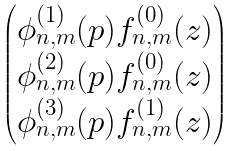Convert formula to latex. <formula><loc_0><loc_0><loc_500><loc_500>\begin{pmatrix} \phi _ { n , m } ^ { ( 1 ) } ( p ) f _ { n , m } ^ { ( 0 ) } ( z ) \\ \phi _ { n , m } ^ { ( 2 ) } ( p ) f _ { n , m } ^ { ( 0 ) } ( z ) \\ \phi _ { n , m } ^ { ( 3 ) } ( p ) f _ { n , m } ^ { ( 1 ) } ( z ) \\ \end{pmatrix}</formula> 